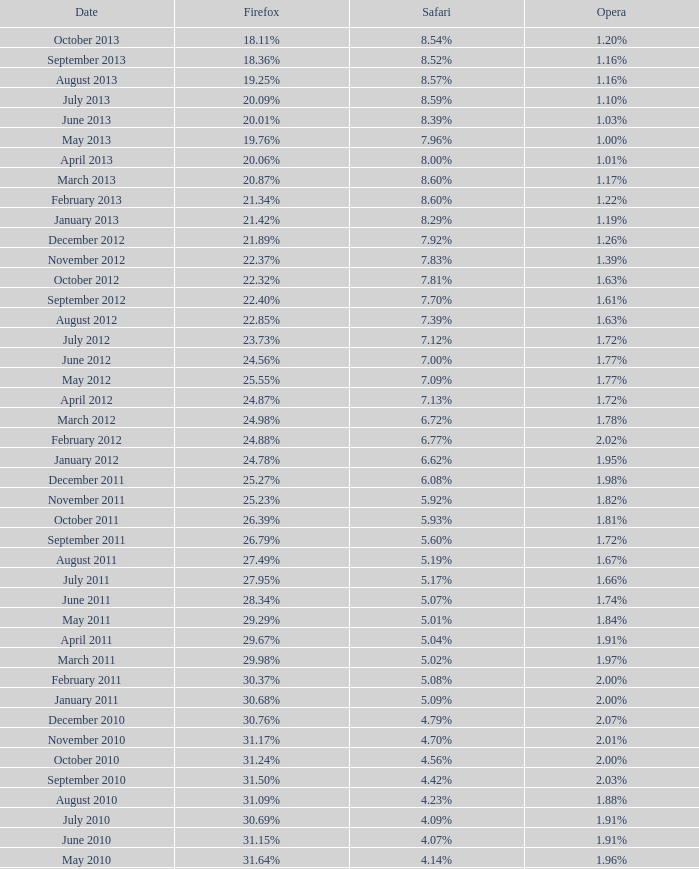What percentage of browsers were using Opera in October 2010? 2.00%. 